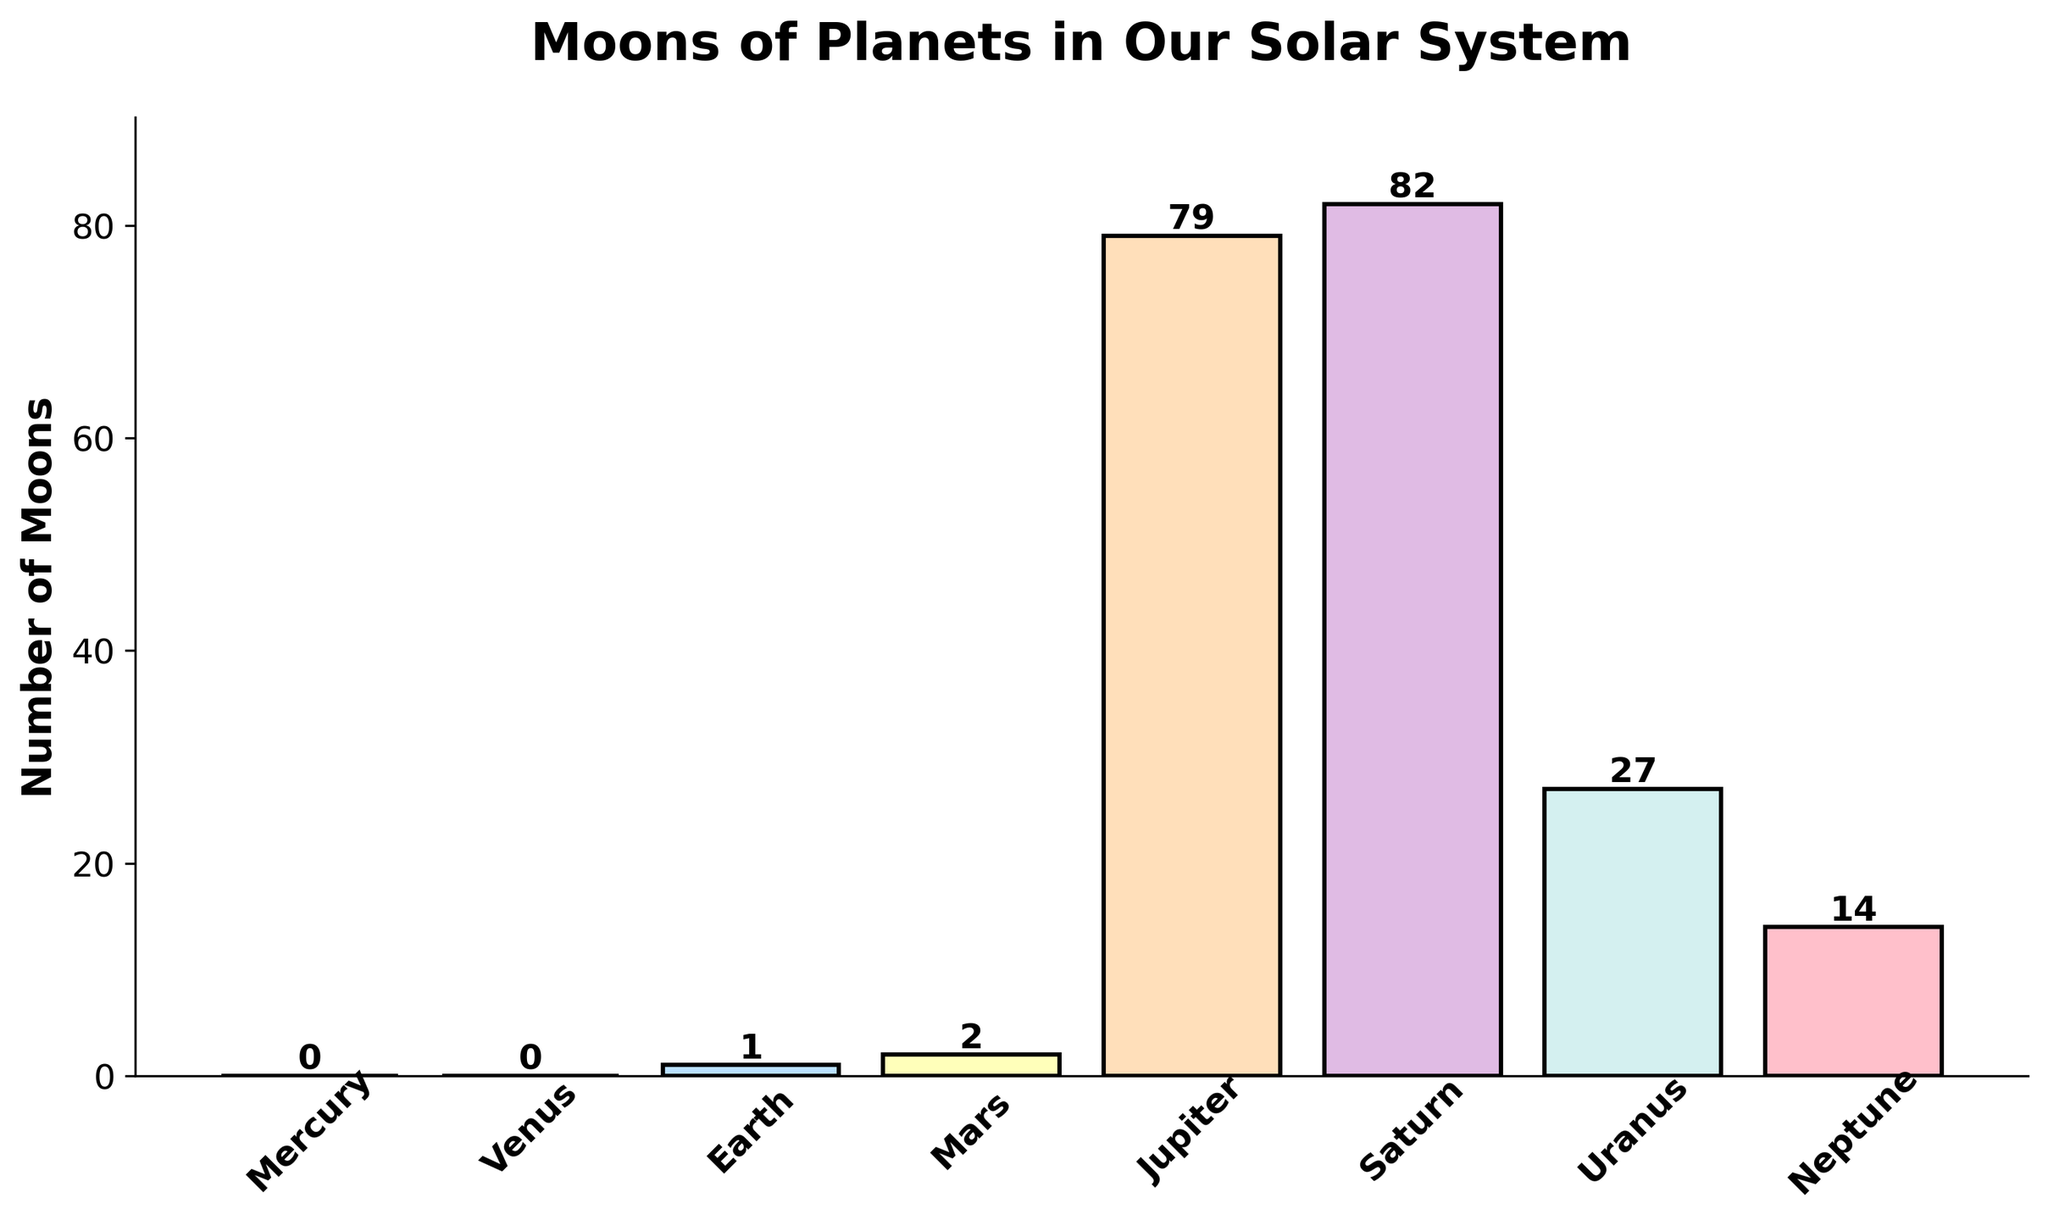Which planet has the most moons? Look at the bar chart and find the tallest bar. The planet with the tallest bar is Saturn, indicating it has the most moons.
Answer: Saturn How many moons does Earth have? Check the label or the bar height for Earth on the chart. The label shows that Earth has 1 moon.
Answer: 1 Are there any planets with no moons? Look for the bars that have a height of 0. Both Mercury and Venus have bars with height 0, indicating they have no moons.
Answer: Yes What is the total number of moons for Mars, Jupiter, and Neptune? Add the number of moons for Mars (2), Jupiter (79), and Neptune (14). 2 + 79 + 14 = 95.
Answer: 95 Which planet has fewer moons: Uranus or Neptune? Compare the heights of the bars for Uranus and Neptune. Uranus has 27 moons while Neptune has 14 moons, so Neptune has fewer moons.
Answer: Neptune What is the average number of moons for the planets that have moons (excluding Mercury and Venus)? First add the number of moons for Earth (1), Mars (2), Jupiter (79), Saturn (82), Uranus (27), and Neptune (14). The total is 205 moons. There are 6 planets with moons, so average = 205/6 = approximately 34.17.
Answer: 34.17 How many more moons does Jupiter have compared to Mars? Subtract the number of moons Mars has from the number of moons Jupiter has: 79 - 2 = 77.
Answer: 77 Which planets have fewer than 10 moons? Look at the bars with heights less than 10. Earth (1 moon) and Mars (2 moons) are the planets with fewer than 10 moons.
Answer: Earth and Mars How much taller is Saturn's bar compared to Earth's bar? Subtract the height of Earth's bar (1 moon) from Saturn's bar (82 moons). 82 - 1 = 81.
Answer: 81 What color is the bar for Neptune? The bar for Neptune is the last one and its color is light blue.
Answer: Light blue 